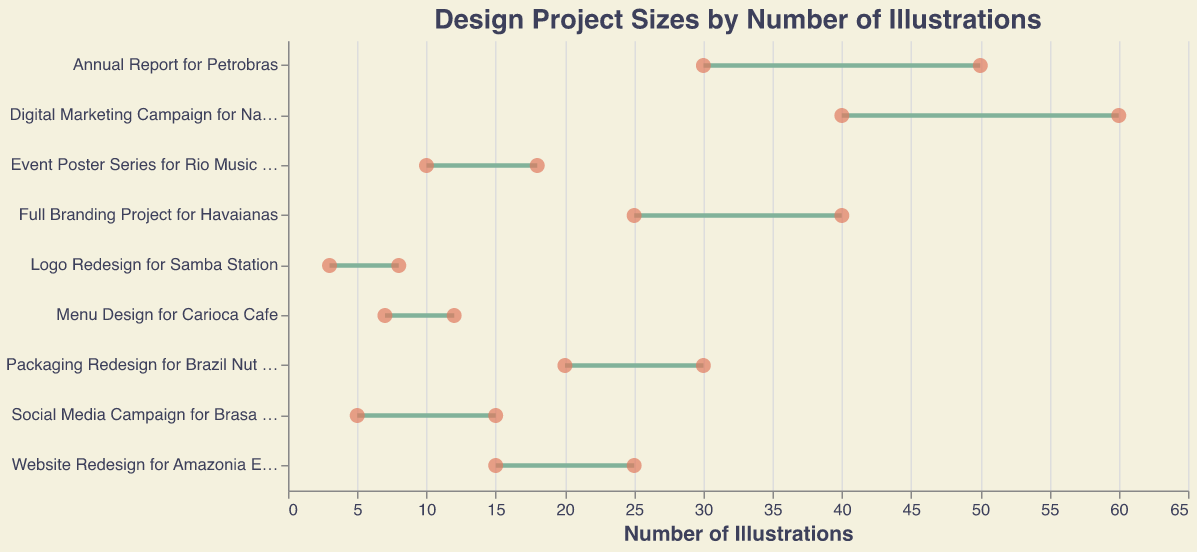What's the title of the figure? The title is usually found at the top of the figure. In this case, it reads "Design Project Sizes by Number of Illustrations".
Answer: Design Project Sizes by Number of Illustrations How many projects are listed for Small clients? The figure lists three projects for Small clients: Social Media Campaign for Brasa Grill, Logo Redesign for Samba Station, and Menu Design for Carioca Cafe.
Answer: 3 Which project has the highest maximum number of illustrations? The project with the highest maximum number of illustrations is indicated by the furthest point on the x-axis. The "Digital Marketing Campaign for Natura Cosmeticos" has the highest maximum at 60 illustrations.
Answer: Digital Marketing Campaign for Natura Cosmeticos What's the difference in the maximum number of illustrations between the largest Small client project and the largest Medium client project? The largest Small client project has a maximum of 15 illustrations (Social Media Campaign for Brasa Grill), and the largest Medium client project has a maximum of 30 illustrations (Packaging Redesign for Brazil Nut Company). The difference is 30 - 15 = 15.
Answer: 15 Which types of clients generally require more illustrations: Small, Medium, or Large? By examining the ranges of the illustration counts, Large clients generally require more illustrations as their ranges (25-60) are higher compare to Small (3-15) and Medium (10-30).
Answer: Large What is the range of illustrations for the smallest Large client project? The smallest Large client project is "Full Branding Project for Havaianas" with a range of 25-40 illustrations.
Answer: 25-40 How many projects have a maximum number of illustrations greater than 20? To find this, count the projects where the max illustrations exceed 20. The projects are "Website Redesign for Amazonia Eco Tours", "Packaging Redesign for Brazil Nut Company", "Annual Report for Petrobras", "Full Branding Project for Havaianas", and "Digital Marketing Campaign for Natura Cosmeticos".
Answer: 5 What's the average minimum number of illustrations required for Medium client projects? The minimum illustrations for Medium client projects are 15, 10, and 20. Average = (15 + 10 + 20) / 3 = 45 / 3 = 15.
Answer: 15 Which project among Small clients has the smallest range of illustrations? The smallest range among Small clients is calculated by Min Illustrations - Max Illustrations. "Logo Redesign for Samba Station" has the range 8 - 3 = 5, which is the smallest compared to the other Small client projects.
Answer: Logo Redesign for Samba Station What's the median maximum number of illustrations across all projects? Listing the maximum values: 8, 12, 15, 18, 25, 30, 40, 50, 60. The median is the middle number when they are sorted, which is 25 in this list.
Answer: 25 